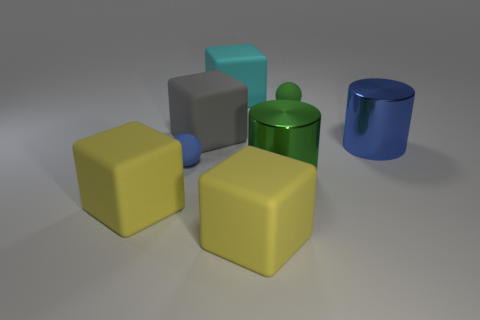Subtract all cyan cubes. How many cubes are left? 3 Subtract all big cyan blocks. How many blocks are left? 3 Subtract all red blocks. Subtract all purple cylinders. How many blocks are left? 4 Add 2 blue metallic objects. How many objects exist? 10 Subtract all cylinders. How many objects are left? 6 Subtract all small green cubes. Subtract all tiny matte spheres. How many objects are left? 6 Add 7 metal objects. How many metal objects are left? 9 Add 2 small blue rubber balls. How many small blue rubber balls exist? 3 Subtract 0 purple cubes. How many objects are left? 8 